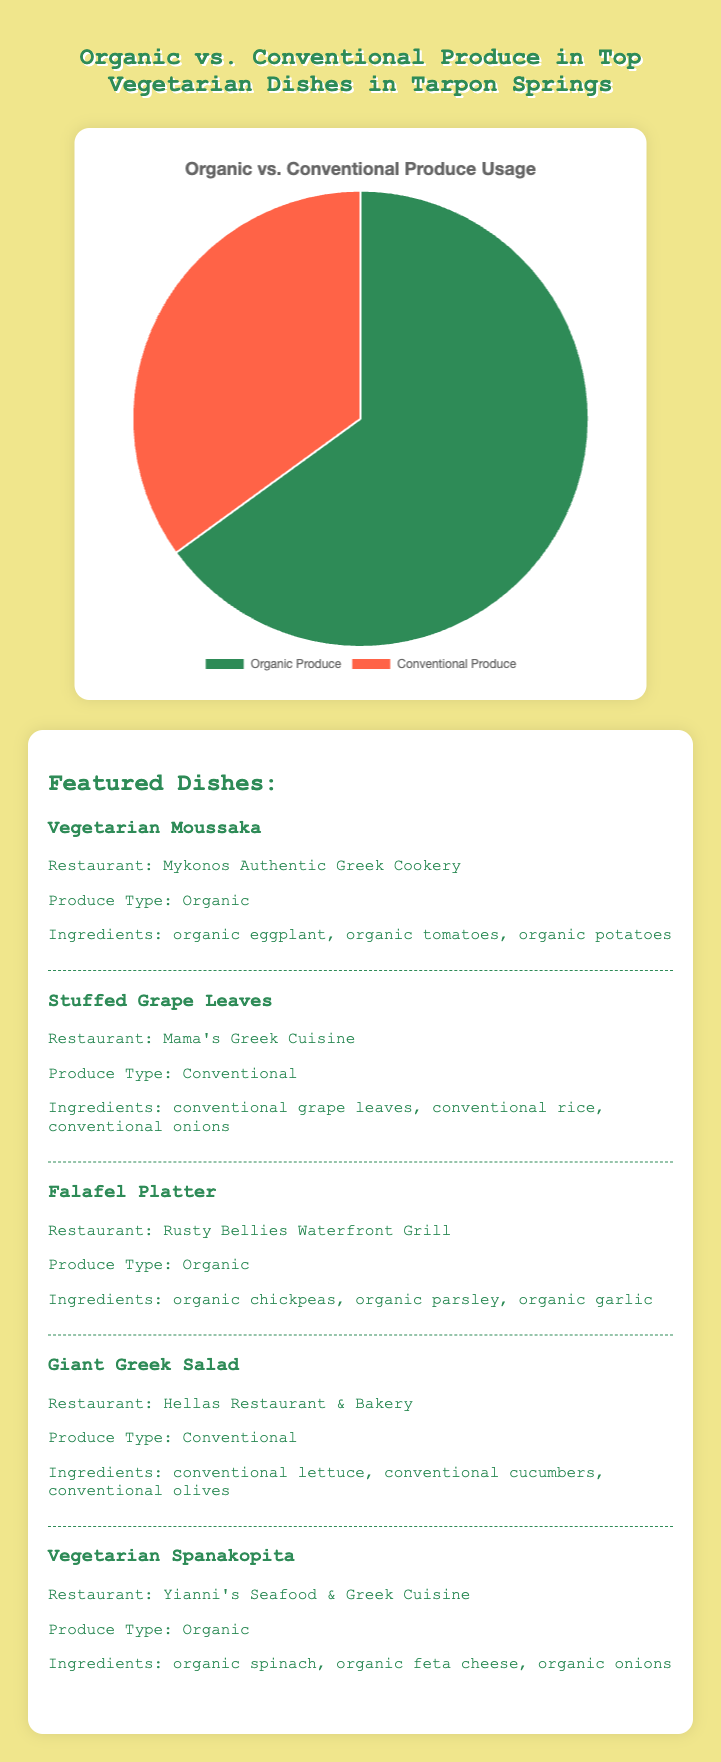How much higher is the percentage of organic produce compared to conventional produce? The percentage of organic produce is 65% and the percentage of conventional produce is 35%. Subtract the percentage of conventional produce from the percentage of organic produce: 65% - 35% = 30%.
Answer: 30% What is the combined percentage of organic and conventional produce? The pie chart shows two percentages: 65% for organic produce and 35% for conventional produce. Add these percentages together: 65% + 35% = 100%.
Answer: 100% Is more than half of the produce used in top vegetarian dishes organic? The pie chart shows that the percentage of organic produce is 65%, which is greater than 50%.
Answer: Yes If the organic produce is represented by green and the conventional produce by red, which type of produce is represented by the red section? The pie chart shows that the organic produce has a higher percentage and is often listed first, and it uses green color; thus, the smaller red section must represent the remaining conventional produce.
Answer: Conventional Produce What fraction of the produce used is conventional? The pie chart shows that conventional produce makes up 35% of the total produce used. To convert this percentage into a fraction, divide by 100: 35/100 = 7/20.
Answer: 7/20 Which type of produce is used more frequently in the top vegetarian dishes? The pie chart shows that organic produce occupies 65% of the total, while conventional produce occupies 35%. Since 65% is greater than 35%, organic produce is used more frequently.
Answer: Organic Produce If the total number of dishes is 10, how many of them would likely use organic produce based on the chart? The chart indicates 65% of produce is organic. To find the number of dishes, multiply 10 by 0.65: 10 * 0.65 = 6.5. Since the number of dishes must be whole, round to the nearest whole number.
Answer: 7 Is the difference in the percentage of organic and conventional produce greater than 25%? The pie chart shows that organic produce is 65% and conventional produce is 35%. The difference is 65% - 35% = 30%, which is indeed greater than 25%.
Answer: Yes What is the ratio of organic to conventional produce usage? The pie chart shows 65% organic and 35% conventional produce. The ratio is 65:35, which simplifies to 13:7 when divided by their greatest common divisor (GCD) of 5.
Answer: 13:7 